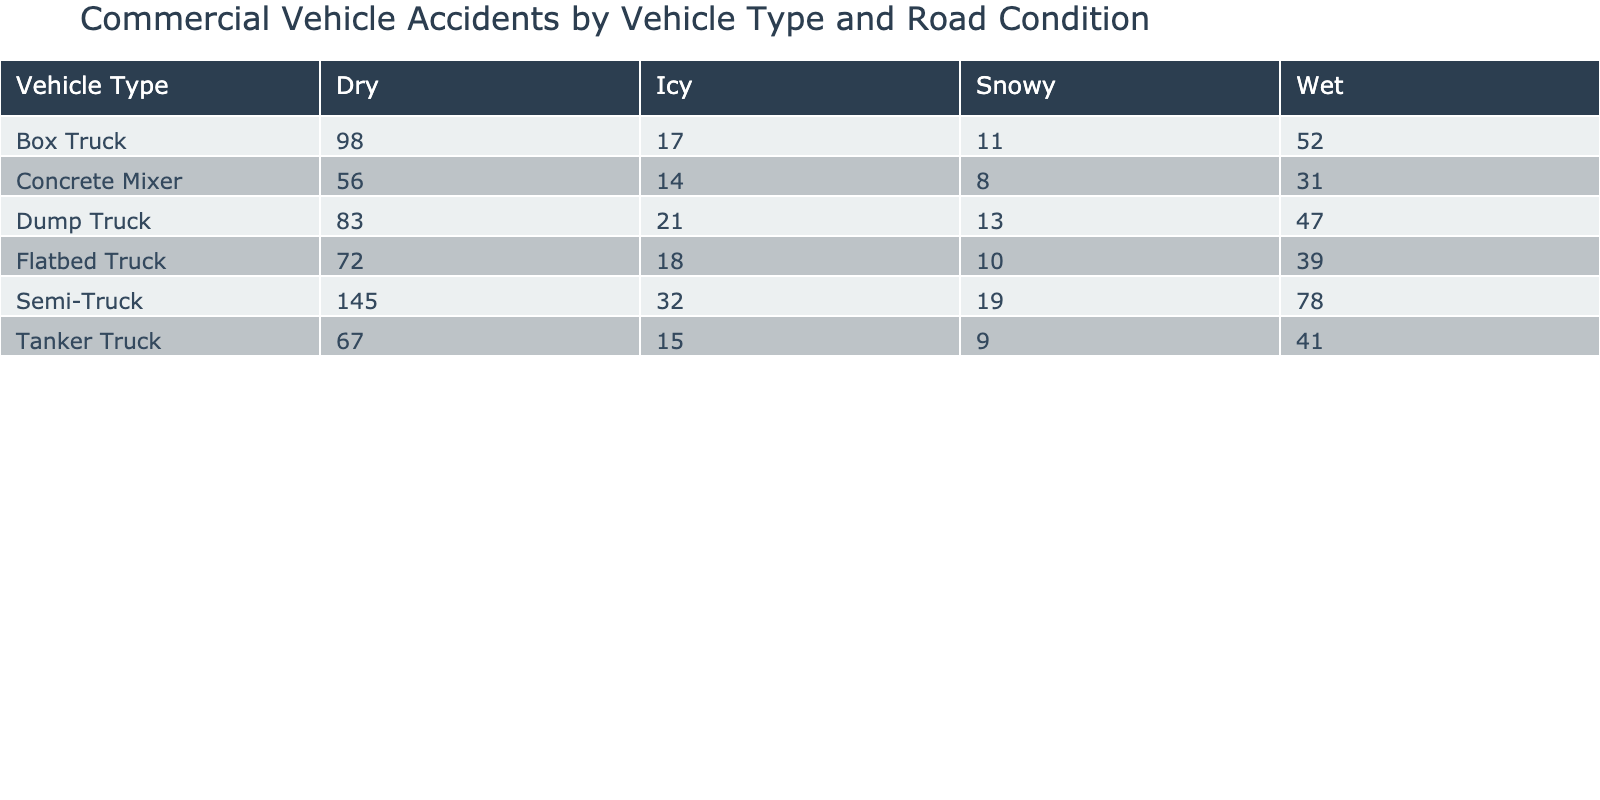What is the highest accident count for a vehicle type on dry roads? The highest accident count for a vehicle type can be found by looking at the "Dry" column. The values are 145 (Semi-Truck), 98 (Box Truck), 67 (Tanker Truck), 83 (Dump Truck), and 72 (Flatbed Truck). The highest value is 145.
Answer: 145 How many accidents did Dump Trucks have on wet roads? To find the number of accidents for Dump Trucks on wet roads, we look at the "Wet" column under the "Dump Truck" row, which shows 47 accidents.
Answer: 47 Which vehicle type had the least number of injuries recorded in wet conditions? The injuries for vehicle types in wet conditions are as follows: Semi-Truck (52), Box Truck (28), Tanker Truck (31), Dump Truck (25), and Flatbed Truck (22). The least is 22 for Flatbed Trucks.
Answer: Flatbed Truck What is the total number of accidents for Tanker Trucks across all road conditions? To calculate the total accidents for Tanker Trucks, we sum the following accident counts: 67 (Dry) + 41 (Wet) + 15 (Icy) + 9 (Snowy) = 132.
Answer: 132 Is it true that the Icy road condition has a higher average damage cost than snowy conditions for any vehicle type? We compare the average damage costs for icy and snowy road conditions across vehicle types. Icy costs are: Semi-Truck (95000), Box Truck (68000), Tanker Truck (120000), Dump Truck (79000), and Flatbed Truck (74000). Snowy costs are: Semi-Truck (88000), Box Truck (61000), Tanker Truck (110000), Dump Truck (72000), and Flatbed Truck (68000). For Tanker Trucks, the icy cost is higher. Therefore, the statement is true for at least one vehicle type.
Answer: Yes What is the average number of fatalities for Box Trucks across all road conditions? We sum the fatalities for Box Trucks: 5 (Dry) + 3 (Wet) + 2 (Icy) + 1 (Snowy) = 11. Then, we divide this by the number of road conditions, which is 4. So, the average is 11/4 = 2.75.
Answer: 2.75 